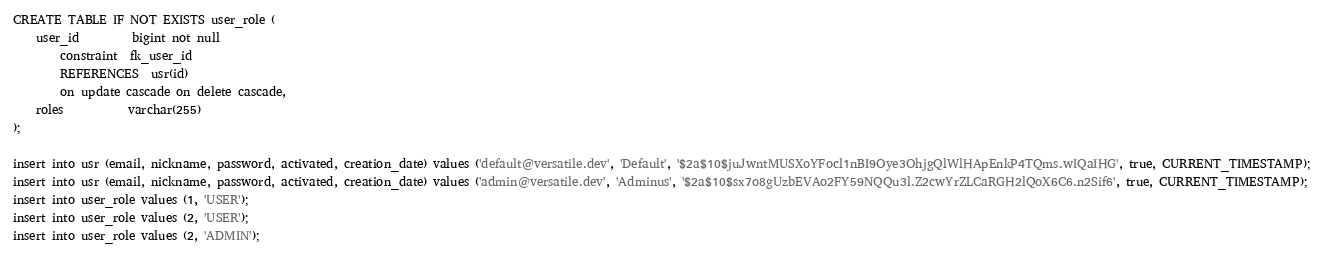Convert code to text. <code><loc_0><loc_0><loc_500><loc_500><_SQL_>
CREATE TABLE IF NOT EXISTS user_role (
    user_id         bigint not null
        constraint  fk_user_id
        REFERENCES  usr(id)
        on update cascade on delete cascade,
    roles           varchar(255)
);

insert into usr (email, nickname, password, activated, creation_date) values ('default@versatile.dev', 'Default', '$2a$10$juJwntMUSXoYFocl1nBI9Oye3OhjgQlWlHApEnkP4TQms.wIQaIHG', true, CURRENT_TIMESTAMP);
insert into usr (email, nickname, password, activated, creation_date) values ('admin@versatile.dev', 'Adminus', '$2a$10$sx7o8gUzbEVAo2FY59NQQu3l.Z2cwYrZLCaRGH2lQoX6C6.n2Sif6', true, CURRENT_TIMESTAMP);
insert into user_role values (1, 'USER');
insert into user_role values (2, 'USER');
insert into user_role values (2, 'ADMIN');</code> 